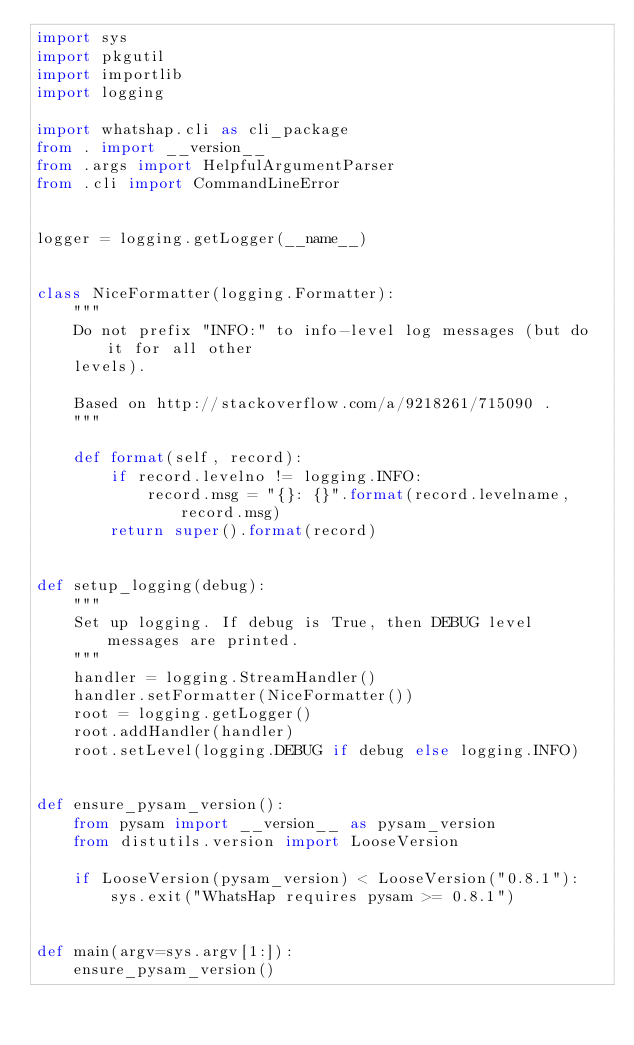Convert code to text. <code><loc_0><loc_0><loc_500><loc_500><_Python_>import sys
import pkgutil
import importlib
import logging

import whatshap.cli as cli_package
from . import __version__
from .args import HelpfulArgumentParser
from .cli import CommandLineError


logger = logging.getLogger(__name__)


class NiceFormatter(logging.Formatter):
    """
    Do not prefix "INFO:" to info-level log messages (but do it for all other
    levels).

    Based on http://stackoverflow.com/a/9218261/715090 .
    """

    def format(self, record):
        if record.levelno != logging.INFO:
            record.msg = "{}: {}".format(record.levelname, record.msg)
        return super().format(record)


def setup_logging(debug):
    """
    Set up logging. If debug is True, then DEBUG level messages are printed.
    """
    handler = logging.StreamHandler()
    handler.setFormatter(NiceFormatter())
    root = logging.getLogger()
    root.addHandler(handler)
    root.setLevel(logging.DEBUG if debug else logging.INFO)


def ensure_pysam_version():
    from pysam import __version__ as pysam_version
    from distutils.version import LooseVersion

    if LooseVersion(pysam_version) < LooseVersion("0.8.1"):
        sys.exit("WhatsHap requires pysam >= 0.8.1")


def main(argv=sys.argv[1:]):
    ensure_pysam_version()</code> 